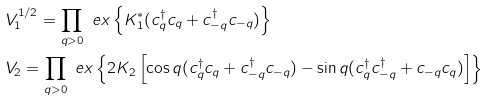<formula> <loc_0><loc_0><loc_500><loc_500>& V _ { 1 } ^ { 1 / 2 } = \prod _ { q > 0 } \ e x \left \{ K _ { 1 } ^ { * } ( c _ { q } ^ { \dag } c _ { q } + c _ { - q } ^ { \dag } c _ { - q } ) \right \} \\ & V _ { 2 } = \prod _ { q > 0 } \ e x \left \{ 2 K _ { 2 } \left [ \cos q ( c _ { q } ^ { \dag } c _ { q } + c _ { - q } ^ { \dag } c _ { - q } ) - \sin q ( c _ { q } ^ { \dag } c _ { - q } ^ { \dag } + c _ { - q } c _ { q } ) \right ] \right \}</formula> 